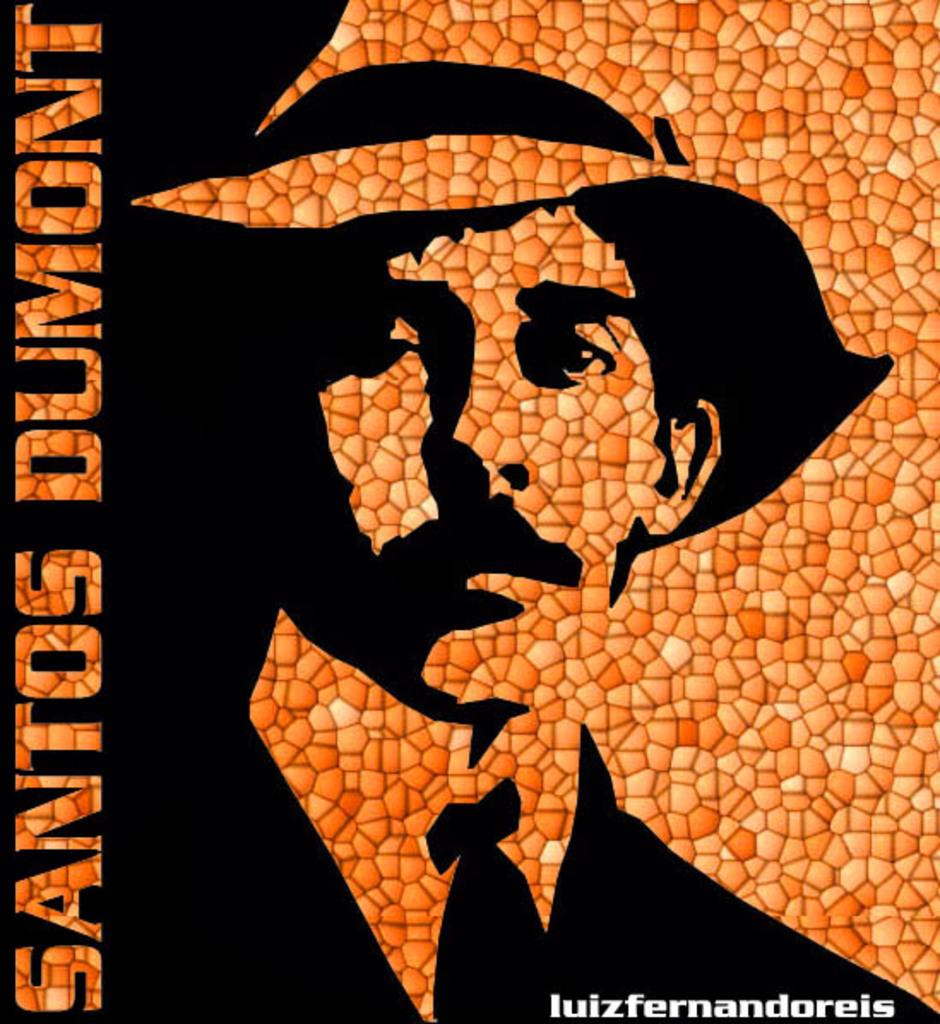What is that man's name?
Give a very brief answer. Santos dumont. What is written on the left?
Provide a succinct answer. Santos dumont. 